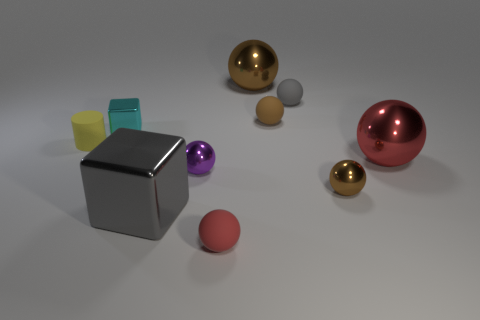How many objects are visible in the image, and can you describe their colors? There are seven objects in the image. Starting from the left, there is a small yellow cylinder, a smaller cyan cube, the large gray cube, a small purple sphere, a small gray sphere, a small gold sphere, and finally a large red sphere. 